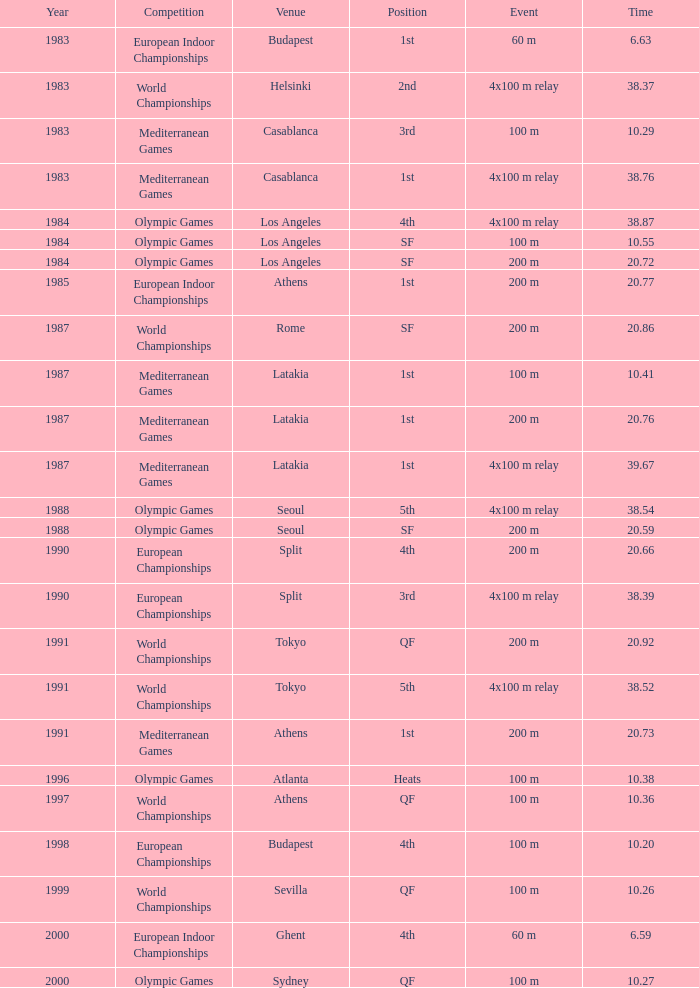29, championship of mediterranean games, and happening of 4x100 m relay? Casablanca, Latakia. 